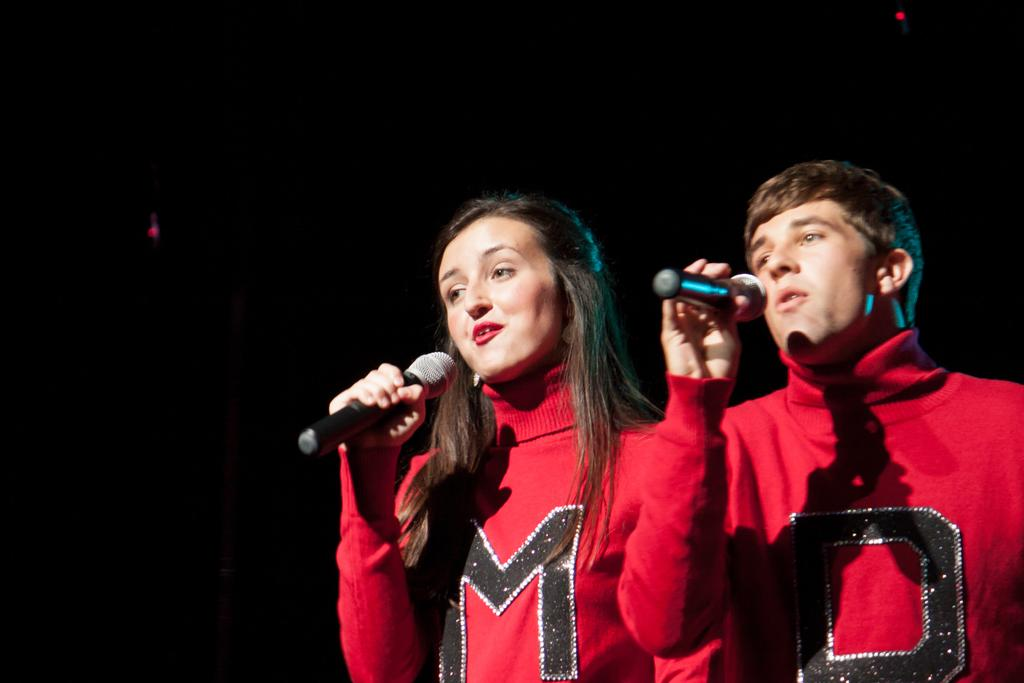How many people are in the image? There are two persons in the image. What are the people wearing? Both persons are wearing red color jackets. What are the people holding in the image? The two persons are holding microphones. Can you describe the position of the woman in the image? There is a woman standing on the left side of the image. What is the woman doing in the image? The woman has her mouth open. What type of joke is the snail telling in the image? There is no snail present in the image, and therefore no joke can be observed. 